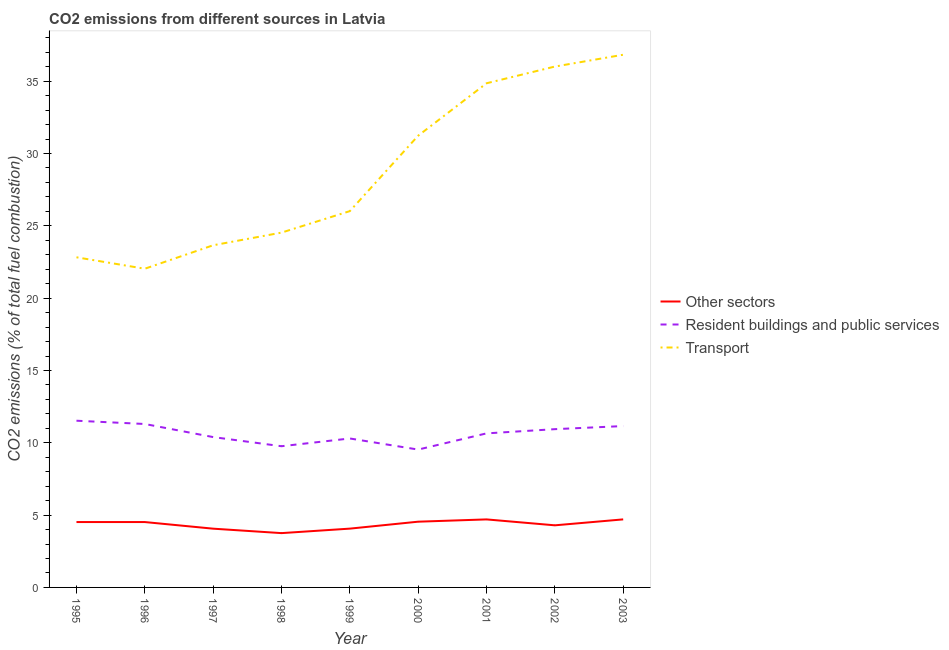Does the line corresponding to percentage of co2 emissions from transport intersect with the line corresponding to percentage of co2 emissions from other sectors?
Your answer should be compact. No. What is the percentage of co2 emissions from transport in 2003?
Keep it short and to the point. 36.83. Across all years, what is the maximum percentage of co2 emissions from other sectors?
Provide a short and direct response. 4.7. Across all years, what is the minimum percentage of co2 emissions from resident buildings and public services?
Offer a very short reply. 9.53. What is the total percentage of co2 emissions from resident buildings and public services in the graph?
Provide a short and direct response. 95.56. What is the difference between the percentage of co2 emissions from other sectors in 1999 and that in 2001?
Your answer should be very brief. -0.64. What is the difference between the percentage of co2 emissions from transport in 1999 and the percentage of co2 emissions from resident buildings and public services in 1998?
Keep it short and to the point. 16.25. What is the average percentage of co2 emissions from resident buildings and public services per year?
Offer a very short reply. 10.62. In the year 1997, what is the difference between the percentage of co2 emissions from transport and percentage of co2 emissions from other sectors?
Provide a short and direct response. 19.59. What is the ratio of the percentage of co2 emissions from transport in 1996 to that in 2001?
Offer a very short reply. 0.63. Is the percentage of co2 emissions from resident buildings and public services in 1997 less than that in 2001?
Keep it short and to the point. Yes. Is the difference between the percentage of co2 emissions from other sectors in 1997 and 1998 greater than the difference between the percentage of co2 emissions from resident buildings and public services in 1997 and 1998?
Your answer should be very brief. No. What is the difference between the highest and the second highest percentage of co2 emissions from other sectors?
Provide a short and direct response. 0. What is the difference between the highest and the lowest percentage of co2 emissions from transport?
Offer a very short reply. 14.79. Is the sum of the percentage of co2 emissions from other sectors in 1996 and 2000 greater than the maximum percentage of co2 emissions from transport across all years?
Offer a terse response. No. Is it the case that in every year, the sum of the percentage of co2 emissions from other sectors and percentage of co2 emissions from resident buildings and public services is greater than the percentage of co2 emissions from transport?
Provide a succinct answer. No. How many lines are there?
Keep it short and to the point. 3. What is the difference between two consecutive major ticks on the Y-axis?
Ensure brevity in your answer.  5. Are the values on the major ticks of Y-axis written in scientific E-notation?
Keep it short and to the point. No. How are the legend labels stacked?
Provide a short and direct response. Vertical. What is the title of the graph?
Your answer should be very brief. CO2 emissions from different sources in Latvia. Does "Unpaid family workers" appear as one of the legend labels in the graph?
Offer a very short reply. No. What is the label or title of the X-axis?
Your answer should be very brief. Year. What is the label or title of the Y-axis?
Keep it short and to the point. CO2 emissions (% of total fuel combustion). What is the CO2 emissions (% of total fuel combustion) of Other sectors in 1995?
Provide a short and direct response. 4.52. What is the CO2 emissions (% of total fuel combustion) of Resident buildings and public services in 1995?
Provide a short and direct response. 11.53. What is the CO2 emissions (% of total fuel combustion) of Transport in 1995?
Make the answer very short. 22.82. What is the CO2 emissions (% of total fuel combustion) in Other sectors in 1996?
Give a very brief answer. 4.52. What is the CO2 emissions (% of total fuel combustion) in Resident buildings and public services in 1996?
Your answer should be very brief. 11.3. What is the CO2 emissions (% of total fuel combustion) of Transport in 1996?
Offer a very short reply. 22.03. What is the CO2 emissions (% of total fuel combustion) of Other sectors in 1997?
Keep it short and to the point. 4.06. What is the CO2 emissions (% of total fuel combustion) in Resident buildings and public services in 1997?
Your answer should be very brief. 10.39. What is the CO2 emissions (% of total fuel combustion) in Transport in 1997?
Ensure brevity in your answer.  23.66. What is the CO2 emissions (% of total fuel combustion) in Other sectors in 1998?
Make the answer very short. 3.75. What is the CO2 emissions (% of total fuel combustion) of Resident buildings and public services in 1998?
Offer a terse response. 9.76. What is the CO2 emissions (% of total fuel combustion) of Transport in 1998?
Your response must be concise. 24.53. What is the CO2 emissions (% of total fuel combustion) of Other sectors in 1999?
Your answer should be very brief. 4.07. What is the CO2 emissions (% of total fuel combustion) in Resident buildings and public services in 1999?
Give a very brief answer. 10.3. What is the CO2 emissions (% of total fuel combustion) of Transport in 1999?
Make the answer very short. 26.02. What is the CO2 emissions (% of total fuel combustion) in Other sectors in 2000?
Offer a terse response. 4.55. What is the CO2 emissions (% of total fuel combustion) in Resident buildings and public services in 2000?
Provide a short and direct response. 9.53. What is the CO2 emissions (% of total fuel combustion) of Transport in 2000?
Provide a succinct answer. 31.23. What is the CO2 emissions (% of total fuel combustion) in Other sectors in 2001?
Your answer should be very brief. 4.7. What is the CO2 emissions (% of total fuel combustion) of Resident buildings and public services in 2001?
Provide a short and direct response. 10.65. What is the CO2 emissions (% of total fuel combustion) in Transport in 2001?
Your answer should be very brief. 34.85. What is the CO2 emissions (% of total fuel combustion) in Other sectors in 2002?
Offer a very short reply. 4.29. What is the CO2 emissions (% of total fuel combustion) in Resident buildings and public services in 2002?
Keep it short and to the point. 10.94. What is the CO2 emissions (% of total fuel combustion) of Transport in 2002?
Give a very brief answer. 36.01. What is the CO2 emissions (% of total fuel combustion) of Other sectors in 2003?
Keep it short and to the point. 4.7. What is the CO2 emissions (% of total fuel combustion) of Resident buildings and public services in 2003?
Offer a very short reply. 11.16. What is the CO2 emissions (% of total fuel combustion) of Transport in 2003?
Provide a short and direct response. 36.83. Across all years, what is the maximum CO2 emissions (% of total fuel combustion) of Other sectors?
Your response must be concise. 4.7. Across all years, what is the maximum CO2 emissions (% of total fuel combustion) of Resident buildings and public services?
Give a very brief answer. 11.53. Across all years, what is the maximum CO2 emissions (% of total fuel combustion) of Transport?
Provide a short and direct response. 36.83. Across all years, what is the minimum CO2 emissions (% of total fuel combustion) of Other sectors?
Give a very brief answer. 3.75. Across all years, what is the minimum CO2 emissions (% of total fuel combustion) of Resident buildings and public services?
Give a very brief answer. 9.53. Across all years, what is the minimum CO2 emissions (% of total fuel combustion) of Transport?
Offer a terse response. 22.03. What is the total CO2 emissions (% of total fuel combustion) of Other sectors in the graph?
Offer a very short reply. 39.17. What is the total CO2 emissions (% of total fuel combustion) in Resident buildings and public services in the graph?
Keep it short and to the point. 95.56. What is the total CO2 emissions (% of total fuel combustion) in Transport in the graph?
Provide a succinct answer. 257.99. What is the difference between the CO2 emissions (% of total fuel combustion) of Resident buildings and public services in 1995 and that in 1996?
Your response must be concise. 0.23. What is the difference between the CO2 emissions (% of total fuel combustion) in Transport in 1995 and that in 1996?
Your answer should be compact. 0.79. What is the difference between the CO2 emissions (% of total fuel combustion) in Other sectors in 1995 and that in 1997?
Your response must be concise. 0.46. What is the difference between the CO2 emissions (% of total fuel combustion) of Resident buildings and public services in 1995 and that in 1997?
Give a very brief answer. 1.13. What is the difference between the CO2 emissions (% of total fuel combustion) of Transport in 1995 and that in 1997?
Make the answer very short. -0.83. What is the difference between the CO2 emissions (% of total fuel combustion) of Other sectors in 1995 and that in 1998?
Your answer should be very brief. 0.77. What is the difference between the CO2 emissions (% of total fuel combustion) in Resident buildings and public services in 1995 and that in 1998?
Your answer should be very brief. 1.76. What is the difference between the CO2 emissions (% of total fuel combustion) of Transport in 1995 and that in 1998?
Give a very brief answer. -1.71. What is the difference between the CO2 emissions (% of total fuel combustion) of Other sectors in 1995 and that in 1999?
Give a very brief answer. 0.45. What is the difference between the CO2 emissions (% of total fuel combustion) in Resident buildings and public services in 1995 and that in 1999?
Your response must be concise. 1.23. What is the difference between the CO2 emissions (% of total fuel combustion) of Transport in 1995 and that in 1999?
Your response must be concise. -3.19. What is the difference between the CO2 emissions (% of total fuel combustion) in Other sectors in 1995 and that in 2000?
Your response must be concise. -0.03. What is the difference between the CO2 emissions (% of total fuel combustion) of Resident buildings and public services in 1995 and that in 2000?
Give a very brief answer. 1.99. What is the difference between the CO2 emissions (% of total fuel combustion) in Transport in 1995 and that in 2000?
Give a very brief answer. -8.41. What is the difference between the CO2 emissions (% of total fuel combustion) in Other sectors in 1995 and that in 2001?
Offer a very short reply. -0.18. What is the difference between the CO2 emissions (% of total fuel combustion) in Resident buildings and public services in 1995 and that in 2001?
Your answer should be very brief. 0.88. What is the difference between the CO2 emissions (% of total fuel combustion) in Transport in 1995 and that in 2001?
Keep it short and to the point. -12.03. What is the difference between the CO2 emissions (% of total fuel combustion) in Other sectors in 1995 and that in 2002?
Your answer should be compact. 0.23. What is the difference between the CO2 emissions (% of total fuel combustion) in Resident buildings and public services in 1995 and that in 2002?
Give a very brief answer. 0.58. What is the difference between the CO2 emissions (% of total fuel combustion) of Transport in 1995 and that in 2002?
Your answer should be very brief. -13.19. What is the difference between the CO2 emissions (% of total fuel combustion) in Other sectors in 1995 and that in 2003?
Give a very brief answer. -0.18. What is the difference between the CO2 emissions (% of total fuel combustion) of Resident buildings and public services in 1995 and that in 2003?
Your answer should be very brief. 0.37. What is the difference between the CO2 emissions (% of total fuel combustion) of Transport in 1995 and that in 2003?
Make the answer very short. -14. What is the difference between the CO2 emissions (% of total fuel combustion) in Other sectors in 1996 and that in 1997?
Offer a very short reply. 0.46. What is the difference between the CO2 emissions (% of total fuel combustion) in Resident buildings and public services in 1996 and that in 1997?
Make the answer very short. 0.91. What is the difference between the CO2 emissions (% of total fuel combustion) of Transport in 1996 and that in 1997?
Ensure brevity in your answer.  -1.62. What is the difference between the CO2 emissions (% of total fuel combustion) in Other sectors in 1996 and that in 1998?
Provide a succinct answer. 0.77. What is the difference between the CO2 emissions (% of total fuel combustion) of Resident buildings and public services in 1996 and that in 1998?
Offer a very short reply. 1.54. What is the difference between the CO2 emissions (% of total fuel combustion) of Transport in 1996 and that in 1998?
Give a very brief answer. -2.5. What is the difference between the CO2 emissions (% of total fuel combustion) in Other sectors in 1996 and that in 1999?
Your answer should be very brief. 0.45. What is the difference between the CO2 emissions (% of total fuel combustion) of Transport in 1996 and that in 1999?
Provide a short and direct response. -3.98. What is the difference between the CO2 emissions (% of total fuel combustion) of Other sectors in 1996 and that in 2000?
Your response must be concise. -0.03. What is the difference between the CO2 emissions (% of total fuel combustion) of Resident buildings and public services in 1996 and that in 2000?
Your answer should be compact. 1.77. What is the difference between the CO2 emissions (% of total fuel combustion) in Transport in 1996 and that in 2000?
Your answer should be very brief. -9.2. What is the difference between the CO2 emissions (% of total fuel combustion) in Other sectors in 1996 and that in 2001?
Your answer should be very brief. -0.18. What is the difference between the CO2 emissions (% of total fuel combustion) in Resident buildings and public services in 1996 and that in 2001?
Your answer should be compact. 0.65. What is the difference between the CO2 emissions (% of total fuel combustion) in Transport in 1996 and that in 2001?
Keep it short and to the point. -12.82. What is the difference between the CO2 emissions (% of total fuel combustion) in Other sectors in 1996 and that in 2002?
Provide a short and direct response. 0.23. What is the difference between the CO2 emissions (% of total fuel combustion) of Resident buildings and public services in 1996 and that in 2002?
Ensure brevity in your answer.  0.36. What is the difference between the CO2 emissions (% of total fuel combustion) in Transport in 1996 and that in 2002?
Offer a very short reply. -13.98. What is the difference between the CO2 emissions (% of total fuel combustion) in Other sectors in 1996 and that in 2003?
Make the answer very short. -0.18. What is the difference between the CO2 emissions (% of total fuel combustion) of Resident buildings and public services in 1996 and that in 2003?
Your answer should be very brief. 0.14. What is the difference between the CO2 emissions (% of total fuel combustion) of Transport in 1996 and that in 2003?
Make the answer very short. -14.79. What is the difference between the CO2 emissions (% of total fuel combustion) of Other sectors in 1997 and that in 1998?
Keep it short and to the point. 0.31. What is the difference between the CO2 emissions (% of total fuel combustion) in Resident buildings and public services in 1997 and that in 1998?
Ensure brevity in your answer.  0.63. What is the difference between the CO2 emissions (% of total fuel combustion) of Transport in 1997 and that in 1998?
Give a very brief answer. -0.87. What is the difference between the CO2 emissions (% of total fuel combustion) in Other sectors in 1997 and that in 1999?
Your response must be concise. -0. What is the difference between the CO2 emissions (% of total fuel combustion) of Resident buildings and public services in 1997 and that in 1999?
Provide a succinct answer. 0.1. What is the difference between the CO2 emissions (% of total fuel combustion) of Transport in 1997 and that in 1999?
Keep it short and to the point. -2.36. What is the difference between the CO2 emissions (% of total fuel combustion) in Other sectors in 1997 and that in 2000?
Your response must be concise. -0.48. What is the difference between the CO2 emissions (% of total fuel combustion) of Resident buildings and public services in 1997 and that in 2000?
Ensure brevity in your answer.  0.86. What is the difference between the CO2 emissions (% of total fuel combustion) in Transport in 1997 and that in 2000?
Provide a succinct answer. -7.58. What is the difference between the CO2 emissions (% of total fuel combustion) in Other sectors in 1997 and that in 2001?
Your answer should be very brief. -0.64. What is the difference between the CO2 emissions (% of total fuel combustion) in Resident buildings and public services in 1997 and that in 2001?
Ensure brevity in your answer.  -0.26. What is the difference between the CO2 emissions (% of total fuel combustion) of Transport in 1997 and that in 2001?
Keep it short and to the point. -11.2. What is the difference between the CO2 emissions (% of total fuel combustion) of Other sectors in 1997 and that in 2002?
Give a very brief answer. -0.23. What is the difference between the CO2 emissions (% of total fuel combustion) of Resident buildings and public services in 1997 and that in 2002?
Offer a very short reply. -0.55. What is the difference between the CO2 emissions (% of total fuel combustion) in Transport in 1997 and that in 2002?
Make the answer very short. -12.36. What is the difference between the CO2 emissions (% of total fuel combustion) in Other sectors in 1997 and that in 2003?
Your response must be concise. -0.64. What is the difference between the CO2 emissions (% of total fuel combustion) of Resident buildings and public services in 1997 and that in 2003?
Your answer should be compact. -0.76. What is the difference between the CO2 emissions (% of total fuel combustion) in Transport in 1997 and that in 2003?
Keep it short and to the point. -13.17. What is the difference between the CO2 emissions (% of total fuel combustion) in Other sectors in 1998 and that in 1999?
Provide a short and direct response. -0.31. What is the difference between the CO2 emissions (% of total fuel combustion) in Resident buildings and public services in 1998 and that in 1999?
Give a very brief answer. -0.54. What is the difference between the CO2 emissions (% of total fuel combustion) of Transport in 1998 and that in 1999?
Your response must be concise. -1.49. What is the difference between the CO2 emissions (% of total fuel combustion) in Other sectors in 1998 and that in 2000?
Provide a succinct answer. -0.79. What is the difference between the CO2 emissions (% of total fuel combustion) of Resident buildings and public services in 1998 and that in 2000?
Offer a terse response. 0.23. What is the difference between the CO2 emissions (% of total fuel combustion) of Transport in 1998 and that in 2000?
Give a very brief answer. -6.7. What is the difference between the CO2 emissions (% of total fuel combustion) of Other sectors in 1998 and that in 2001?
Ensure brevity in your answer.  -0.95. What is the difference between the CO2 emissions (% of total fuel combustion) in Resident buildings and public services in 1998 and that in 2001?
Provide a succinct answer. -0.89. What is the difference between the CO2 emissions (% of total fuel combustion) of Transport in 1998 and that in 2001?
Provide a short and direct response. -10.32. What is the difference between the CO2 emissions (% of total fuel combustion) of Other sectors in 1998 and that in 2002?
Make the answer very short. -0.54. What is the difference between the CO2 emissions (% of total fuel combustion) in Resident buildings and public services in 1998 and that in 2002?
Offer a terse response. -1.18. What is the difference between the CO2 emissions (% of total fuel combustion) in Transport in 1998 and that in 2002?
Ensure brevity in your answer.  -11.48. What is the difference between the CO2 emissions (% of total fuel combustion) of Other sectors in 1998 and that in 2003?
Make the answer very short. -0.95. What is the difference between the CO2 emissions (% of total fuel combustion) in Resident buildings and public services in 1998 and that in 2003?
Keep it short and to the point. -1.39. What is the difference between the CO2 emissions (% of total fuel combustion) in Transport in 1998 and that in 2003?
Your response must be concise. -12.3. What is the difference between the CO2 emissions (% of total fuel combustion) in Other sectors in 1999 and that in 2000?
Give a very brief answer. -0.48. What is the difference between the CO2 emissions (% of total fuel combustion) of Resident buildings and public services in 1999 and that in 2000?
Make the answer very short. 0.77. What is the difference between the CO2 emissions (% of total fuel combustion) in Transport in 1999 and that in 2000?
Ensure brevity in your answer.  -5.22. What is the difference between the CO2 emissions (% of total fuel combustion) of Other sectors in 1999 and that in 2001?
Offer a very short reply. -0.64. What is the difference between the CO2 emissions (% of total fuel combustion) in Resident buildings and public services in 1999 and that in 2001?
Your answer should be very brief. -0.35. What is the difference between the CO2 emissions (% of total fuel combustion) in Transport in 1999 and that in 2001?
Provide a succinct answer. -8.84. What is the difference between the CO2 emissions (% of total fuel combustion) in Other sectors in 1999 and that in 2002?
Offer a very short reply. -0.23. What is the difference between the CO2 emissions (% of total fuel combustion) of Resident buildings and public services in 1999 and that in 2002?
Provide a succinct answer. -0.64. What is the difference between the CO2 emissions (% of total fuel combustion) of Transport in 1999 and that in 2002?
Provide a short and direct response. -9.99. What is the difference between the CO2 emissions (% of total fuel combustion) in Other sectors in 1999 and that in 2003?
Provide a succinct answer. -0.64. What is the difference between the CO2 emissions (% of total fuel combustion) in Resident buildings and public services in 1999 and that in 2003?
Provide a succinct answer. -0.86. What is the difference between the CO2 emissions (% of total fuel combustion) in Transport in 1999 and that in 2003?
Offer a terse response. -10.81. What is the difference between the CO2 emissions (% of total fuel combustion) in Other sectors in 2000 and that in 2001?
Offer a terse response. -0.16. What is the difference between the CO2 emissions (% of total fuel combustion) in Resident buildings and public services in 2000 and that in 2001?
Your response must be concise. -1.12. What is the difference between the CO2 emissions (% of total fuel combustion) in Transport in 2000 and that in 2001?
Provide a succinct answer. -3.62. What is the difference between the CO2 emissions (% of total fuel combustion) of Other sectors in 2000 and that in 2002?
Make the answer very short. 0.25. What is the difference between the CO2 emissions (% of total fuel combustion) in Resident buildings and public services in 2000 and that in 2002?
Ensure brevity in your answer.  -1.41. What is the difference between the CO2 emissions (% of total fuel combustion) in Transport in 2000 and that in 2002?
Keep it short and to the point. -4.78. What is the difference between the CO2 emissions (% of total fuel combustion) in Other sectors in 2000 and that in 2003?
Your answer should be compact. -0.16. What is the difference between the CO2 emissions (% of total fuel combustion) in Resident buildings and public services in 2000 and that in 2003?
Your answer should be compact. -1.63. What is the difference between the CO2 emissions (% of total fuel combustion) in Transport in 2000 and that in 2003?
Make the answer very short. -5.6. What is the difference between the CO2 emissions (% of total fuel combustion) of Other sectors in 2001 and that in 2002?
Offer a terse response. 0.41. What is the difference between the CO2 emissions (% of total fuel combustion) of Resident buildings and public services in 2001 and that in 2002?
Make the answer very short. -0.29. What is the difference between the CO2 emissions (% of total fuel combustion) in Transport in 2001 and that in 2002?
Keep it short and to the point. -1.16. What is the difference between the CO2 emissions (% of total fuel combustion) in Other sectors in 2001 and that in 2003?
Ensure brevity in your answer.  -0. What is the difference between the CO2 emissions (% of total fuel combustion) of Resident buildings and public services in 2001 and that in 2003?
Offer a terse response. -0.51. What is the difference between the CO2 emissions (% of total fuel combustion) in Transport in 2001 and that in 2003?
Keep it short and to the point. -1.97. What is the difference between the CO2 emissions (% of total fuel combustion) in Other sectors in 2002 and that in 2003?
Your answer should be very brief. -0.41. What is the difference between the CO2 emissions (% of total fuel combustion) of Resident buildings and public services in 2002 and that in 2003?
Your answer should be compact. -0.21. What is the difference between the CO2 emissions (% of total fuel combustion) of Transport in 2002 and that in 2003?
Make the answer very short. -0.82. What is the difference between the CO2 emissions (% of total fuel combustion) in Other sectors in 1995 and the CO2 emissions (% of total fuel combustion) in Resident buildings and public services in 1996?
Provide a succinct answer. -6.78. What is the difference between the CO2 emissions (% of total fuel combustion) of Other sectors in 1995 and the CO2 emissions (% of total fuel combustion) of Transport in 1996?
Your response must be concise. -17.51. What is the difference between the CO2 emissions (% of total fuel combustion) of Resident buildings and public services in 1995 and the CO2 emissions (% of total fuel combustion) of Transport in 1996?
Keep it short and to the point. -10.51. What is the difference between the CO2 emissions (% of total fuel combustion) of Other sectors in 1995 and the CO2 emissions (% of total fuel combustion) of Resident buildings and public services in 1997?
Offer a very short reply. -5.87. What is the difference between the CO2 emissions (% of total fuel combustion) in Other sectors in 1995 and the CO2 emissions (% of total fuel combustion) in Transport in 1997?
Provide a short and direct response. -19.14. What is the difference between the CO2 emissions (% of total fuel combustion) of Resident buildings and public services in 1995 and the CO2 emissions (% of total fuel combustion) of Transport in 1997?
Provide a succinct answer. -12.13. What is the difference between the CO2 emissions (% of total fuel combustion) of Other sectors in 1995 and the CO2 emissions (% of total fuel combustion) of Resident buildings and public services in 1998?
Keep it short and to the point. -5.24. What is the difference between the CO2 emissions (% of total fuel combustion) in Other sectors in 1995 and the CO2 emissions (% of total fuel combustion) in Transport in 1998?
Your answer should be compact. -20.01. What is the difference between the CO2 emissions (% of total fuel combustion) of Resident buildings and public services in 1995 and the CO2 emissions (% of total fuel combustion) of Transport in 1998?
Offer a terse response. -13.01. What is the difference between the CO2 emissions (% of total fuel combustion) in Other sectors in 1995 and the CO2 emissions (% of total fuel combustion) in Resident buildings and public services in 1999?
Make the answer very short. -5.78. What is the difference between the CO2 emissions (% of total fuel combustion) of Other sectors in 1995 and the CO2 emissions (% of total fuel combustion) of Transport in 1999?
Provide a succinct answer. -21.5. What is the difference between the CO2 emissions (% of total fuel combustion) in Resident buildings and public services in 1995 and the CO2 emissions (% of total fuel combustion) in Transport in 1999?
Make the answer very short. -14.49. What is the difference between the CO2 emissions (% of total fuel combustion) of Other sectors in 1995 and the CO2 emissions (% of total fuel combustion) of Resident buildings and public services in 2000?
Make the answer very short. -5.01. What is the difference between the CO2 emissions (% of total fuel combustion) of Other sectors in 1995 and the CO2 emissions (% of total fuel combustion) of Transport in 2000?
Provide a succinct answer. -26.71. What is the difference between the CO2 emissions (% of total fuel combustion) of Resident buildings and public services in 1995 and the CO2 emissions (% of total fuel combustion) of Transport in 2000?
Your answer should be very brief. -19.71. What is the difference between the CO2 emissions (% of total fuel combustion) in Other sectors in 1995 and the CO2 emissions (% of total fuel combustion) in Resident buildings and public services in 2001?
Offer a terse response. -6.13. What is the difference between the CO2 emissions (% of total fuel combustion) in Other sectors in 1995 and the CO2 emissions (% of total fuel combustion) in Transport in 2001?
Give a very brief answer. -30.34. What is the difference between the CO2 emissions (% of total fuel combustion) of Resident buildings and public services in 1995 and the CO2 emissions (% of total fuel combustion) of Transport in 2001?
Offer a very short reply. -23.33. What is the difference between the CO2 emissions (% of total fuel combustion) in Other sectors in 1995 and the CO2 emissions (% of total fuel combustion) in Resident buildings and public services in 2002?
Make the answer very short. -6.42. What is the difference between the CO2 emissions (% of total fuel combustion) of Other sectors in 1995 and the CO2 emissions (% of total fuel combustion) of Transport in 2002?
Provide a succinct answer. -31.49. What is the difference between the CO2 emissions (% of total fuel combustion) in Resident buildings and public services in 1995 and the CO2 emissions (% of total fuel combustion) in Transport in 2002?
Provide a short and direct response. -24.49. What is the difference between the CO2 emissions (% of total fuel combustion) of Other sectors in 1995 and the CO2 emissions (% of total fuel combustion) of Resident buildings and public services in 2003?
Keep it short and to the point. -6.64. What is the difference between the CO2 emissions (% of total fuel combustion) in Other sectors in 1995 and the CO2 emissions (% of total fuel combustion) in Transport in 2003?
Provide a succinct answer. -32.31. What is the difference between the CO2 emissions (% of total fuel combustion) of Resident buildings and public services in 1995 and the CO2 emissions (% of total fuel combustion) of Transport in 2003?
Give a very brief answer. -25.3. What is the difference between the CO2 emissions (% of total fuel combustion) of Other sectors in 1996 and the CO2 emissions (% of total fuel combustion) of Resident buildings and public services in 1997?
Make the answer very short. -5.87. What is the difference between the CO2 emissions (% of total fuel combustion) of Other sectors in 1996 and the CO2 emissions (% of total fuel combustion) of Transport in 1997?
Offer a terse response. -19.14. What is the difference between the CO2 emissions (% of total fuel combustion) in Resident buildings and public services in 1996 and the CO2 emissions (% of total fuel combustion) in Transport in 1997?
Keep it short and to the point. -12.36. What is the difference between the CO2 emissions (% of total fuel combustion) of Other sectors in 1996 and the CO2 emissions (% of total fuel combustion) of Resident buildings and public services in 1998?
Provide a succinct answer. -5.24. What is the difference between the CO2 emissions (% of total fuel combustion) of Other sectors in 1996 and the CO2 emissions (% of total fuel combustion) of Transport in 1998?
Your response must be concise. -20.01. What is the difference between the CO2 emissions (% of total fuel combustion) of Resident buildings and public services in 1996 and the CO2 emissions (% of total fuel combustion) of Transport in 1998?
Provide a succinct answer. -13.23. What is the difference between the CO2 emissions (% of total fuel combustion) of Other sectors in 1996 and the CO2 emissions (% of total fuel combustion) of Resident buildings and public services in 1999?
Give a very brief answer. -5.78. What is the difference between the CO2 emissions (% of total fuel combustion) in Other sectors in 1996 and the CO2 emissions (% of total fuel combustion) in Transport in 1999?
Make the answer very short. -21.5. What is the difference between the CO2 emissions (% of total fuel combustion) of Resident buildings and public services in 1996 and the CO2 emissions (% of total fuel combustion) of Transport in 1999?
Offer a very short reply. -14.72. What is the difference between the CO2 emissions (% of total fuel combustion) of Other sectors in 1996 and the CO2 emissions (% of total fuel combustion) of Resident buildings and public services in 2000?
Give a very brief answer. -5.01. What is the difference between the CO2 emissions (% of total fuel combustion) in Other sectors in 1996 and the CO2 emissions (% of total fuel combustion) in Transport in 2000?
Provide a succinct answer. -26.71. What is the difference between the CO2 emissions (% of total fuel combustion) of Resident buildings and public services in 1996 and the CO2 emissions (% of total fuel combustion) of Transport in 2000?
Offer a very short reply. -19.93. What is the difference between the CO2 emissions (% of total fuel combustion) of Other sectors in 1996 and the CO2 emissions (% of total fuel combustion) of Resident buildings and public services in 2001?
Ensure brevity in your answer.  -6.13. What is the difference between the CO2 emissions (% of total fuel combustion) in Other sectors in 1996 and the CO2 emissions (% of total fuel combustion) in Transport in 2001?
Offer a very short reply. -30.34. What is the difference between the CO2 emissions (% of total fuel combustion) of Resident buildings and public services in 1996 and the CO2 emissions (% of total fuel combustion) of Transport in 2001?
Your answer should be compact. -23.56. What is the difference between the CO2 emissions (% of total fuel combustion) of Other sectors in 1996 and the CO2 emissions (% of total fuel combustion) of Resident buildings and public services in 2002?
Your response must be concise. -6.42. What is the difference between the CO2 emissions (% of total fuel combustion) of Other sectors in 1996 and the CO2 emissions (% of total fuel combustion) of Transport in 2002?
Your answer should be very brief. -31.49. What is the difference between the CO2 emissions (% of total fuel combustion) of Resident buildings and public services in 1996 and the CO2 emissions (% of total fuel combustion) of Transport in 2002?
Offer a very short reply. -24.71. What is the difference between the CO2 emissions (% of total fuel combustion) of Other sectors in 1996 and the CO2 emissions (% of total fuel combustion) of Resident buildings and public services in 2003?
Give a very brief answer. -6.64. What is the difference between the CO2 emissions (% of total fuel combustion) of Other sectors in 1996 and the CO2 emissions (% of total fuel combustion) of Transport in 2003?
Your answer should be compact. -32.31. What is the difference between the CO2 emissions (% of total fuel combustion) of Resident buildings and public services in 1996 and the CO2 emissions (% of total fuel combustion) of Transport in 2003?
Provide a short and direct response. -25.53. What is the difference between the CO2 emissions (% of total fuel combustion) of Other sectors in 1997 and the CO2 emissions (% of total fuel combustion) of Resident buildings and public services in 1998?
Provide a succinct answer. -5.7. What is the difference between the CO2 emissions (% of total fuel combustion) of Other sectors in 1997 and the CO2 emissions (% of total fuel combustion) of Transport in 1998?
Make the answer very short. -20.47. What is the difference between the CO2 emissions (% of total fuel combustion) in Resident buildings and public services in 1997 and the CO2 emissions (% of total fuel combustion) in Transport in 1998?
Your answer should be very brief. -14.14. What is the difference between the CO2 emissions (% of total fuel combustion) of Other sectors in 1997 and the CO2 emissions (% of total fuel combustion) of Resident buildings and public services in 1999?
Offer a very short reply. -6.24. What is the difference between the CO2 emissions (% of total fuel combustion) of Other sectors in 1997 and the CO2 emissions (% of total fuel combustion) of Transport in 1999?
Your response must be concise. -21.95. What is the difference between the CO2 emissions (% of total fuel combustion) of Resident buildings and public services in 1997 and the CO2 emissions (% of total fuel combustion) of Transport in 1999?
Your answer should be compact. -15.62. What is the difference between the CO2 emissions (% of total fuel combustion) in Other sectors in 1997 and the CO2 emissions (% of total fuel combustion) in Resident buildings and public services in 2000?
Give a very brief answer. -5.47. What is the difference between the CO2 emissions (% of total fuel combustion) in Other sectors in 1997 and the CO2 emissions (% of total fuel combustion) in Transport in 2000?
Your answer should be very brief. -27.17. What is the difference between the CO2 emissions (% of total fuel combustion) of Resident buildings and public services in 1997 and the CO2 emissions (% of total fuel combustion) of Transport in 2000?
Your answer should be very brief. -20.84. What is the difference between the CO2 emissions (% of total fuel combustion) of Other sectors in 1997 and the CO2 emissions (% of total fuel combustion) of Resident buildings and public services in 2001?
Give a very brief answer. -6.59. What is the difference between the CO2 emissions (% of total fuel combustion) in Other sectors in 1997 and the CO2 emissions (% of total fuel combustion) in Transport in 2001?
Provide a succinct answer. -30.79. What is the difference between the CO2 emissions (% of total fuel combustion) of Resident buildings and public services in 1997 and the CO2 emissions (% of total fuel combustion) of Transport in 2001?
Provide a short and direct response. -24.46. What is the difference between the CO2 emissions (% of total fuel combustion) in Other sectors in 1997 and the CO2 emissions (% of total fuel combustion) in Resident buildings and public services in 2002?
Give a very brief answer. -6.88. What is the difference between the CO2 emissions (% of total fuel combustion) in Other sectors in 1997 and the CO2 emissions (% of total fuel combustion) in Transport in 2002?
Keep it short and to the point. -31.95. What is the difference between the CO2 emissions (% of total fuel combustion) of Resident buildings and public services in 1997 and the CO2 emissions (% of total fuel combustion) of Transport in 2002?
Offer a terse response. -25.62. What is the difference between the CO2 emissions (% of total fuel combustion) in Other sectors in 1997 and the CO2 emissions (% of total fuel combustion) in Resident buildings and public services in 2003?
Your response must be concise. -7.09. What is the difference between the CO2 emissions (% of total fuel combustion) in Other sectors in 1997 and the CO2 emissions (% of total fuel combustion) in Transport in 2003?
Make the answer very short. -32.77. What is the difference between the CO2 emissions (% of total fuel combustion) of Resident buildings and public services in 1997 and the CO2 emissions (% of total fuel combustion) of Transport in 2003?
Give a very brief answer. -26.43. What is the difference between the CO2 emissions (% of total fuel combustion) of Other sectors in 1998 and the CO2 emissions (% of total fuel combustion) of Resident buildings and public services in 1999?
Your answer should be compact. -6.54. What is the difference between the CO2 emissions (% of total fuel combustion) of Other sectors in 1998 and the CO2 emissions (% of total fuel combustion) of Transport in 1999?
Offer a very short reply. -22.26. What is the difference between the CO2 emissions (% of total fuel combustion) of Resident buildings and public services in 1998 and the CO2 emissions (% of total fuel combustion) of Transport in 1999?
Make the answer very short. -16.25. What is the difference between the CO2 emissions (% of total fuel combustion) in Other sectors in 1998 and the CO2 emissions (% of total fuel combustion) in Resident buildings and public services in 2000?
Provide a short and direct response. -5.78. What is the difference between the CO2 emissions (% of total fuel combustion) in Other sectors in 1998 and the CO2 emissions (% of total fuel combustion) in Transport in 2000?
Offer a terse response. -27.48. What is the difference between the CO2 emissions (% of total fuel combustion) in Resident buildings and public services in 1998 and the CO2 emissions (% of total fuel combustion) in Transport in 2000?
Your answer should be very brief. -21.47. What is the difference between the CO2 emissions (% of total fuel combustion) of Other sectors in 1998 and the CO2 emissions (% of total fuel combustion) of Resident buildings and public services in 2001?
Keep it short and to the point. -6.9. What is the difference between the CO2 emissions (% of total fuel combustion) of Other sectors in 1998 and the CO2 emissions (% of total fuel combustion) of Transport in 2001?
Offer a terse response. -31.1. What is the difference between the CO2 emissions (% of total fuel combustion) in Resident buildings and public services in 1998 and the CO2 emissions (% of total fuel combustion) in Transport in 2001?
Give a very brief answer. -25.09. What is the difference between the CO2 emissions (% of total fuel combustion) in Other sectors in 1998 and the CO2 emissions (% of total fuel combustion) in Resident buildings and public services in 2002?
Provide a short and direct response. -7.19. What is the difference between the CO2 emissions (% of total fuel combustion) of Other sectors in 1998 and the CO2 emissions (% of total fuel combustion) of Transport in 2002?
Offer a terse response. -32.26. What is the difference between the CO2 emissions (% of total fuel combustion) in Resident buildings and public services in 1998 and the CO2 emissions (% of total fuel combustion) in Transport in 2002?
Keep it short and to the point. -26.25. What is the difference between the CO2 emissions (% of total fuel combustion) of Other sectors in 1998 and the CO2 emissions (% of total fuel combustion) of Resident buildings and public services in 2003?
Give a very brief answer. -7.4. What is the difference between the CO2 emissions (% of total fuel combustion) of Other sectors in 1998 and the CO2 emissions (% of total fuel combustion) of Transport in 2003?
Provide a short and direct response. -33.07. What is the difference between the CO2 emissions (% of total fuel combustion) in Resident buildings and public services in 1998 and the CO2 emissions (% of total fuel combustion) in Transport in 2003?
Provide a short and direct response. -27.07. What is the difference between the CO2 emissions (% of total fuel combustion) in Other sectors in 1999 and the CO2 emissions (% of total fuel combustion) in Resident buildings and public services in 2000?
Your response must be concise. -5.47. What is the difference between the CO2 emissions (% of total fuel combustion) of Other sectors in 1999 and the CO2 emissions (% of total fuel combustion) of Transport in 2000?
Provide a succinct answer. -27.17. What is the difference between the CO2 emissions (% of total fuel combustion) of Resident buildings and public services in 1999 and the CO2 emissions (% of total fuel combustion) of Transport in 2000?
Ensure brevity in your answer.  -20.93. What is the difference between the CO2 emissions (% of total fuel combustion) of Other sectors in 1999 and the CO2 emissions (% of total fuel combustion) of Resident buildings and public services in 2001?
Give a very brief answer. -6.58. What is the difference between the CO2 emissions (% of total fuel combustion) of Other sectors in 1999 and the CO2 emissions (% of total fuel combustion) of Transport in 2001?
Your answer should be very brief. -30.79. What is the difference between the CO2 emissions (% of total fuel combustion) of Resident buildings and public services in 1999 and the CO2 emissions (% of total fuel combustion) of Transport in 2001?
Your response must be concise. -24.56. What is the difference between the CO2 emissions (% of total fuel combustion) of Other sectors in 1999 and the CO2 emissions (% of total fuel combustion) of Resident buildings and public services in 2002?
Offer a very short reply. -6.88. What is the difference between the CO2 emissions (% of total fuel combustion) of Other sectors in 1999 and the CO2 emissions (% of total fuel combustion) of Transport in 2002?
Give a very brief answer. -31.95. What is the difference between the CO2 emissions (% of total fuel combustion) in Resident buildings and public services in 1999 and the CO2 emissions (% of total fuel combustion) in Transport in 2002?
Offer a very short reply. -25.71. What is the difference between the CO2 emissions (% of total fuel combustion) in Other sectors in 1999 and the CO2 emissions (% of total fuel combustion) in Resident buildings and public services in 2003?
Offer a very short reply. -7.09. What is the difference between the CO2 emissions (% of total fuel combustion) of Other sectors in 1999 and the CO2 emissions (% of total fuel combustion) of Transport in 2003?
Your answer should be compact. -32.76. What is the difference between the CO2 emissions (% of total fuel combustion) of Resident buildings and public services in 1999 and the CO2 emissions (% of total fuel combustion) of Transport in 2003?
Keep it short and to the point. -26.53. What is the difference between the CO2 emissions (% of total fuel combustion) of Other sectors in 2000 and the CO2 emissions (% of total fuel combustion) of Resident buildings and public services in 2001?
Your response must be concise. -6.1. What is the difference between the CO2 emissions (% of total fuel combustion) of Other sectors in 2000 and the CO2 emissions (% of total fuel combustion) of Transport in 2001?
Your answer should be compact. -30.31. What is the difference between the CO2 emissions (% of total fuel combustion) in Resident buildings and public services in 2000 and the CO2 emissions (% of total fuel combustion) in Transport in 2001?
Your response must be concise. -25.32. What is the difference between the CO2 emissions (% of total fuel combustion) of Other sectors in 2000 and the CO2 emissions (% of total fuel combustion) of Resident buildings and public services in 2002?
Keep it short and to the point. -6.4. What is the difference between the CO2 emissions (% of total fuel combustion) in Other sectors in 2000 and the CO2 emissions (% of total fuel combustion) in Transport in 2002?
Your response must be concise. -31.47. What is the difference between the CO2 emissions (% of total fuel combustion) in Resident buildings and public services in 2000 and the CO2 emissions (% of total fuel combustion) in Transport in 2002?
Offer a terse response. -26.48. What is the difference between the CO2 emissions (% of total fuel combustion) of Other sectors in 2000 and the CO2 emissions (% of total fuel combustion) of Resident buildings and public services in 2003?
Ensure brevity in your answer.  -6.61. What is the difference between the CO2 emissions (% of total fuel combustion) in Other sectors in 2000 and the CO2 emissions (% of total fuel combustion) in Transport in 2003?
Make the answer very short. -32.28. What is the difference between the CO2 emissions (% of total fuel combustion) in Resident buildings and public services in 2000 and the CO2 emissions (% of total fuel combustion) in Transport in 2003?
Give a very brief answer. -27.3. What is the difference between the CO2 emissions (% of total fuel combustion) of Other sectors in 2001 and the CO2 emissions (% of total fuel combustion) of Resident buildings and public services in 2002?
Provide a short and direct response. -6.24. What is the difference between the CO2 emissions (% of total fuel combustion) of Other sectors in 2001 and the CO2 emissions (% of total fuel combustion) of Transport in 2002?
Make the answer very short. -31.31. What is the difference between the CO2 emissions (% of total fuel combustion) in Resident buildings and public services in 2001 and the CO2 emissions (% of total fuel combustion) in Transport in 2002?
Your answer should be compact. -25.36. What is the difference between the CO2 emissions (% of total fuel combustion) of Other sectors in 2001 and the CO2 emissions (% of total fuel combustion) of Resident buildings and public services in 2003?
Provide a succinct answer. -6.45. What is the difference between the CO2 emissions (% of total fuel combustion) of Other sectors in 2001 and the CO2 emissions (% of total fuel combustion) of Transport in 2003?
Your response must be concise. -32.13. What is the difference between the CO2 emissions (% of total fuel combustion) of Resident buildings and public services in 2001 and the CO2 emissions (% of total fuel combustion) of Transport in 2003?
Ensure brevity in your answer.  -26.18. What is the difference between the CO2 emissions (% of total fuel combustion) of Other sectors in 2002 and the CO2 emissions (% of total fuel combustion) of Resident buildings and public services in 2003?
Give a very brief answer. -6.86. What is the difference between the CO2 emissions (% of total fuel combustion) in Other sectors in 2002 and the CO2 emissions (% of total fuel combustion) in Transport in 2003?
Offer a very short reply. -32.53. What is the difference between the CO2 emissions (% of total fuel combustion) of Resident buildings and public services in 2002 and the CO2 emissions (% of total fuel combustion) of Transport in 2003?
Your response must be concise. -25.89. What is the average CO2 emissions (% of total fuel combustion) in Other sectors per year?
Ensure brevity in your answer.  4.35. What is the average CO2 emissions (% of total fuel combustion) in Resident buildings and public services per year?
Your response must be concise. 10.62. What is the average CO2 emissions (% of total fuel combustion) in Transport per year?
Your answer should be very brief. 28.67. In the year 1995, what is the difference between the CO2 emissions (% of total fuel combustion) in Other sectors and CO2 emissions (% of total fuel combustion) in Resident buildings and public services?
Your answer should be very brief. -7.01. In the year 1995, what is the difference between the CO2 emissions (% of total fuel combustion) in Other sectors and CO2 emissions (% of total fuel combustion) in Transport?
Your answer should be very brief. -18.31. In the year 1995, what is the difference between the CO2 emissions (% of total fuel combustion) of Resident buildings and public services and CO2 emissions (% of total fuel combustion) of Transport?
Your answer should be very brief. -11.3. In the year 1996, what is the difference between the CO2 emissions (% of total fuel combustion) of Other sectors and CO2 emissions (% of total fuel combustion) of Resident buildings and public services?
Your answer should be very brief. -6.78. In the year 1996, what is the difference between the CO2 emissions (% of total fuel combustion) of Other sectors and CO2 emissions (% of total fuel combustion) of Transport?
Offer a terse response. -17.51. In the year 1996, what is the difference between the CO2 emissions (% of total fuel combustion) in Resident buildings and public services and CO2 emissions (% of total fuel combustion) in Transport?
Offer a very short reply. -10.73. In the year 1997, what is the difference between the CO2 emissions (% of total fuel combustion) of Other sectors and CO2 emissions (% of total fuel combustion) of Resident buildings and public services?
Ensure brevity in your answer.  -6.33. In the year 1997, what is the difference between the CO2 emissions (% of total fuel combustion) in Other sectors and CO2 emissions (% of total fuel combustion) in Transport?
Provide a succinct answer. -19.59. In the year 1997, what is the difference between the CO2 emissions (% of total fuel combustion) of Resident buildings and public services and CO2 emissions (% of total fuel combustion) of Transport?
Make the answer very short. -13.26. In the year 1998, what is the difference between the CO2 emissions (% of total fuel combustion) in Other sectors and CO2 emissions (% of total fuel combustion) in Resident buildings and public services?
Give a very brief answer. -6.01. In the year 1998, what is the difference between the CO2 emissions (% of total fuel combustion) of Other sectors and CO2 emissions (% of total fuel combustion) of Transport?
Provide a succinct answer. -20.78. In the year 1998, what is the difference between the CO2 emissions (% of total fuel combustion) in Resident buildings and public services and CO2 emissions (% of total fuel combustion) in Transport?
Keep it short and to the point. -14.77. In the year 1999, what is the difference between the CO2 emissions (% of total fuel combustion) in Other sectors and CO2 emissions (% of total fuel combustion) in Resident buildings and public services?
Give a very brief answer. -6.23. In the year 1999, what is the difference between the CO2 emissions (% of total fuel combustion) of Other sectors and CO2 emissions (% of total fuel combustion) of Transport?
Provide a short and direct response. -21.95. In the year 1999, what is the difference between the CO2 emissions (% of total fuel combustion) in Resident buildings and public services and CO2 emissions (% of total fuel combustion) in Transport?
Give a very brief answer. -15.72. In the year 2000, what is the difference between the CO2 emissions (% of total fuel combustion) of Other sectors and CO2 emissions (% of total fuel combustion) of Resident buildings and public services?
Your answer should be very brief. -4.99. In the year 2000, what is the difference between the CO2 emissions (% of total fuel combustion) of Other sectors and CO2 emissions (% of total fuel combustion) of Transport?
Your answer should be compact. -26.69. In the year 2000, what is the difference between the CO2 emissions (% of total fuel combustion) in Resident buildings and public services and CO2 emissions (% of total fuel combustion) in Transport?
Your answer should be very brief. -21.7. In the year 2001, what is the difference between the CO2 emissions (% of total fuel combustion) of Other sectors and CO2 emissions (% of total fuel combustion) of Resident buildings and public services?
Provide a succinct answer. -5.95. In the year 2001, what is the difference between the CO2 emissions (% of total fuel combustion) of Other sectors and CO2 emissions (% of total fuel combustion) of Transport?
Your answer should be very brief. -30.15. In the year 2001, what is the difference between the CO2 emissions (% of total fuel combustion) of Resident buildings and public services and CO2 emissions (% of total fuel combustion) of Transport?
Your response must be concise. -24.2. In the year 2002, what is the difference between the CO2 emissions (% of total fuel combustion) in Other sectors and CO2 emissions (% of total fuel combustion) in Resident buildings and public services?
Offer a very short reply. -6.65. In the year 2002, what is the difference between the CO2 emissions (% of total fuel combustion) in Other sectors and CO2 emissions (% of total fuel combustion) in Transport?
Your answer should be compact. -31.72. In the year 2002, what is the difference between the CO2 emissions (% of total fuel combustion) of Resident buildings and public services and CO2 emissions (% of total fuel combustion) of Transport?
Your answer should be compact. -25.07. In the year 2003, what is the difference between the CO2 emissions (% of total fuel combustion) in Other sectors and CO2 emissions (% of total fuel combustion) in Resident buildings and public services?
Your answer should be very brief. -6.45. In the year 2003, what is the difference between the CO2 emissions (% of total fuel combustion) of Other sectors and CO2 emissions (% of total fuel combustion) of Transport?
Ensure brevity in your answer.  -32.12. In the year 2003, what is the difference between the CO2 emissions (% of total fuel combustion) in Resident buildings and public services and CO2 emissions (% of total fuel combustion) in Transport?
Offer a very short reply. -25.67. What is the ratio of the CO2 emissions (% of total fuel combustion) of Resident buildings and public services in 1995 to that in 1996?
Give a very brief answer. 1.02. What is the ratio of the CO2 emissions (% of total fuel combustion) in Transport in 1995 to that in 1996?
Your answer should be very brief. 1.04. What is the ratio of the CO2 emissions (% of total fuel combustion) in Other sectors in 1995 to that in 1997?
Your response must be concise. 1.11. What is the ratio of the CO2 emissions (% of total fuel combustion) in Resident buildings and public services in 1995 to that in 1997?
Offer a very short reply. 1.11. What is the ratio of the CO2 emissions (% of total fuel combustion) in Transport in 1995 to that in 1997?
Ensure brevity in your answer.  0.96. What is the ratio of the CO2 emissions (% of total fuel combustion) in Other sectors in 1995 to that in 1998?
Make the answer very short. 1.2. What is the ratio of the CO2 emissions (% of total fuel combustion) of Resident buildings and public services in 1995 to that in 1998?
Ensure brevity in your answer.  1.18. What is the ratio of the CO2 emissions (% of total fuel combustion) of Transport in 1995 to that in 1998?
Provide a succinct answer. 0.93. What is the ratio of the CO2 emissions (% of total fuel combustion) of Other sectors in 1995 to that in 1999?
Give a very brief answer. 1.11. What is the ratio of the CO2 emissions (% of total fuel combustion) in Resident buildings and public services in 1995 to that in 1999?
Your answer should be very brief. 1.12. What is the ratio of the CO2 emissions (% of total fuel combustion) of Transport in 1995 to that in 1999?
Give a very brief answer. 0.88. What is the ratio of the CO2 emissions (% of total fuel combustion) of Other sectors in 1995 to that in 2000?
Provide a succinct answer. 0.99. What is the ratio of the CO2 emissions (% of total fuel combustion) of Resident buildings and public services in 1995 to that in 2000?
Provide a short and direct response. 1.21. What is the ratio of the CO2 emissions (% of total fuel combustion) of Transport in 1995 to that in 2000?
Provide a succinct answer. 0.73. What is the ratio of the CO2 emissions (% of total fuel combustion) in Other sectors in 1995 to that in 2001?
Provide a short and direct response. 0.96. What is the ratio of the CO2 emissions (% of total fuel combustion) of Resident buildings and public services in 1995 to that in 2001?
Your response must be concise. 1.08. What is the ratio of the CO2 emissions (% of total fuel combustion) of Transport in 1995 to that in 2001?
Make the answer very short. 0.65. What is the ratio of the CO2 emissions (% of total fuel combustion) in Other sectors in 1995 to that in 2002?
Provide a succinct answer. 1.05. What is the ratio of the CO2 emissions (% of total fuel combustion) in Resident buildings and public services in 1995 to that in 2002?
Offer a very short reply. 1.05. What is the ratio of the CO2 emissions (% of total fuel combustion) in Transport in 1995 to that in 2002?
Give a very brief answer. 0.63. What is the ratio of the CO2 emissions (% of total fuel combustion) of Other sectors in 1995 to that in 2003?
Your response must be concise. 0.96. What is the ratio of the CO2 emissions (% of total fuel combustion) in Resident buildings and public services in 1995 to that in 2003?
Ensure brevity in your answer.  1.03. What is the ratio of the CO2 emissions (% of total fuel combustion) in Transport in 1995 to that in 2003?
Keep it short and to the point. 0.62. What is the ratio of the CO2 emissions (% of total fuel combustion) in Other sectors in 1996 to that in 1997?
Your answer should be compact. 1.11. What is the ratio of the CO2 emissions (% of total fuel combustion) of Resident buildings and public services in 1996 to that in 1997?
Your answer should be compact. 1.09. What is the ratio of the CO2 emissions (% of total fuel combustion) of Transport in 1996 to that in 1997?
Keep it short and to the point. 0.93. What is the ratio of the CO2 emissions (% of total fuel combustion) of Other sectors in 1996 to that in 1998?
Provide a succinct answer. 1.2. What is the ratio of the CO2 emissions (% of total fuel combustion) of Resident buildings and public services in 1996 to that in 1998?
Offer a terse response. 1.16. What is the ratio of the CO2 emissions (% of total fuel combustion) in Transport in 1996 to that in 1998?
Your response must be concise. 0.9. What is the ratio of the CO2 emissions (% of total fuel combustion) of Other sectors in 1996 to that in 1999?
Provide a succinct answer. 1.11. What is the ratio of the CO2 emissions (% of total fuel combustion) of Resident buildings and public services in 1996 to that in 1999?
Make the answer very short. 1.1. What is the ratio of the CO2 emissions (% of total fuel combustion) in Transport in 1996 to that in 1999?
Ensure brevity in your answer.  0.85. What is the ratio of the CO2 emissions (% of total fuel combustion) in Resident buildings and public services in 1996 to that in 2000?
Make the answer very short. 1.19. What is the ratio of the CO2 emissions (% of total fuel combustion) in Transport in 1996 to that in 2000?
Make the answer very short. 0.71. What is the ratio of the CO2 emissions (% of total fuel combustion) in Other sectors in 1996 to that in 2001?
Provide a succinct answer. 0.96. What is the ratio of the CO2 emissions (% of total fuel combustion) of Resident buildings and public services in 1996 to that in 2001?
Ensure brevity in your answer.  1.06. What is the ratio of the CO2 emissions (% of total fuel combustion) in Transport in 1996 to that in 2001?
Provide a succinct answer. 0.63. What is the ratio of the CO2 emissions (% of total fuel combustion) in Other sectors in 1996 to that in 2002?
Provide a short and direct response. 1.05. What is the ratio of the CO2 emissions (% of total fuel combustion) of Resident buildings and public services in 1996 to that in 2002?
Provide a succinct answer. 1.03. What is the ratio of the CO2 emissions (% of total fuel combustion) in Transport in 1996 to that in 2002?
Give a very brief answer. 0.61. What is the ratio of the CO2 emissions (% of total fuel combustion) in Other sectors in 1996 to that in 2003?
Offer a terse response. 0.96. What is the ratio of the CO2 emissions (% of total fuel combustion) of Resident buildings and public services in 1996 to that in 2003?
Offer a very short reply. 1.01. What is the ratio of the CO2 emissions (% of total fuel combustion) in Transport in 1996 to that in 2003?
Your response must be concise. 0.6. What is the ratio of the CO2 emissions (% of total fuel combustion) in Other sectors in 1997 to that in 1998?
Provide a short and direct response. 1.08. What is the ratio of the CO2 emissions (% of total fuel combustion) in Resident buildings and public services in 1997 to that in 1998?
Keep it short and to the point. 1.06. What is the ratio of the CO2 emissions (% of total fuel combustion) of Transport in 1997 to that in 1998?
Offer a very short reply. 0.96. What is the ratio of the CO2 emissions (% of total fuel combustion) in Other sectors in 1997 to that in 1999?
Offer a terse response. 1. What is the ratio of the CO2 emissions (% of total fuel combustion) in Resident buildings and public services in 1997 to that in 1999?
Offer a very short reply. 1.01. What is the ratio of the CO2 emissions (% of total fuel combustion) of Transport in 1997 to that in 1999?
Keep it short and to the point. 0.91. What is the ratio of the CO2 emissions (% of total fuel combustion) in Other sectors in 1997 to that in 2000?
Offer a terse response. 0.89. What is the ratio of the CO2 emissions (% of total fuel combustion) in Resident buildings and public services in 1997 to that in 2000?
Your answer should be very brief. 1.09. What is the ratio of the CO2 emissions (% of total fuel combustion) in Transport in 1997 to that in 2000?
Your answer should be very brief. 0.76. What is the ratio of the CO2 emissions (% of total fuel combustion) in Other sectors in 1997 to that in 2001?
Your answer should be very brief. 0.86. What is the ratio of the CO2 emissions (% of total fuel combustion) of Transport in 1997 to that in 2001?
Make the answer very short. 0.68. What is the ratio of the CO2 emissions (% of total fuel combustion) of Other sectors in 1997 to that in 2002?
Your answer should be compact. 0.95. What is the ratio of the CO2 emissions (% of total fuel combustion) in Resident buildings and public services in 1997 to that in 2002?
Keep it short and to the point. 0.95. What is the ratio of the CO2 emissions (% of total fuel combustion) in Transport in 1997 to that in 2002?
Offer a very short reply. 0.66. What is the ratio of the CO2 emissions (% of total fuel combustion) in Other sectors in 1997 to that in 2003?
Your answer should be compact. 0.86. What is the ratio of the CO2 emissions (% of total fuel combustion) in Resident buildings and public services in 1997 to that in 2003?
Ensure brevity in your answer.  0.93. What is the ratio of the CO2 emissions (% of total fuel combustion) of Transport in 1997 to that in 2003?
Provide a succinct answer. 0.64. What is the ratio of the CO2 emissions (% of total fuel combustion) of Other sectors in 1998 to that in 1999?
Provide a short and direct response. 0.92. What is the ratio of the CO2 emissions (% of total fuel combustion) of Resident buildings and public services in 1998 to that in 1999?
Your response must be concise. 0.95. What is the ratio of the CO2 emissions (% of total fuel combustion) in Transport in 1998 to that in 1999?
Give a very brief answer. 0.94. What is the ratio of the CO2 emissions (% of total fuel combustion) in Other sectors in 1998 to that in 2000?
Keep it short and to the point. 0.83. What is the ratio of the CO2 emissions (% of total fuel combustion) of Resident buildings and public services in 1998 to that in 2000?
Your answer should be compact. 1.02. What is the ratio of the CO2 emissions (% of total fuel combustion) in Transport in 1998 to that in 2000?
Ensure brevity in your answer.  0.79. What is the ratio of the CO2 emissions (% of total fuel combustion) of Other sectors in 1998 to that in 2001?
Make the answer very short. 0.8. What is the ratio of the CO2 emissions (% of total fuel combustion) of Resident buildings and public services in 1998 to that in 2001?
Give a very brief answer. 0.92. What is the ratio of the CO2 emissions (% of total fuel combustion) of Transport in 1998 to that in 2001?
Provide a succinct answer. 0.7. What is the ratio of the CO2 emissions (% of total fuel combustion) in Other sectors in 1998 to that in 2002?
Your response must be concise. 0.87. What is the ratio of the CO2 emissions (% of total fuel combustion) in Resident buildings and public services in 1998 to that in 2002?
Your answer should be very brief. 0.89. What is the ratio of the CO2 emissions (% of total fuel combustion) in Transport in 1998 to that in 2002?
Your answer should be very brief. 0.68. What is the ratio of the CO2 emissions (% of total fuel combustion) in Other sectors in 1998 to that in 2003?
Make the answer very short. 0.8. What is the ratio of the CO2 emissions (% of total fuel combustion) in Resident buildings and public services in 1998 to that in 2003?
Your answer should be very brief. 0.88. What is the ratio of the CO2 emissions (% of total fuel combustion) of Transport in 1998 to that in 2003?
Keep it short and to the point. 0.67. What is the ratio of the CO2 emissions (% of total fuel combustion) in Other sectors in 1999 to that in 2000?
Your answer should be very brief. 0.89. What is the ratio of the CO2 emissions (% of total fuel combustion) of Resident buildings and public services in 1999 to that in 2000?
Make the answer very short. 1.08. What is the ratio of the CO2 emissions (% of total fuel combustion) in Transport in 1999 to that in 2000?
Offer a terse response. 0.83. What is the ratio of the CO2 emissions (% of total fuel combustion) in Other sectors in 1999 to that in 2001?
Ensure brevity in your answer.  0.86. What is the ratio of the CO2 emissions (% of total fuel combustion) in Resident buildings and public services in 1999 to that in 2001?
Your response must be concise. 0.97. What is the ratio of the CO2 emissions (% of total fuel combustion) in Transport in 1999 to that in 2001?
Make the answer very short. 0.75. What is the ratio of the CO2 emissions (% of total fuel combustion) of Other sectors in 1999 to that in 2002?
Make the answer very short. 0.95. What is the ratio of the CO2 emissions (% of total fuel combustion) in Transport in 1999 to that in 2002?
Your answer should be very brief. 0.72. What is the ratio of the CO2 emissions (% of total fuel combustion) of Other sectors in 1999 to that in 2003?
Offer a very short reply. 0.86. What is the ratio of the CO2 emissions (% of total fuel combustion) in Transport in 1999 to that in 2003?
Provide a succinct answer. 0.71. What is the ratio of the CO2 emissions (% of total fuel combustion) in Other sectors in 2000 to that in 2001?
Offer a very short reply. 0.97. What is the ratio of the CO2 emissions (% of total fuel combustion) in Resident buildings and public services in 2000 to that in 2001?
Offer a very short reply. 0.89. What is the ratio of the CO2 emissions (% of total fuel combustion) in Transport in 2000 to that in 2001?
Offer a very short reply. 0.9. What is the ratio of the CO2 emissions (% of total fuel combustion) in Other sectors in 2000 to that in 2002?
Give a very brief answer. 1.06. What is the ratio of the CO2 emissions (% of total fuel combustion) in Resident buildings and public services in 2000 to that in 2002?
Your answer should be very brief. 0.87. What is the ratio of the CO2 emissions (% of total fuel combustion) of Transport in 2000 to that in 2002?
Make the answer very short. 0.87. What is the ratio of the CO2 emissions (% of total fuel combustion) of Other sectors in 2000 to that in 2003?
Offer a very short reply. 0.97. What is the ratio of the CO2 emissions (% of total fuel combustion) of Resident buildings and public services in 2000 to that in 2003?
Offer a very short reply. 0.85. What is the ratio of the CO2 emissions (% of total fuel combustion) of Transport in 2000 to that in 2003?
Offer a terse response. 0.85. What is the ratio of the CO2 emissions (% of total fuel combustion) of Other sectors in 2001 to that in 2002?
Make the answer very short. 1.1. What is the ratio of the CO2 emissions (% of total fuel combustion) in Resident buildings and public services in 2001 to that in 2002?
Ensure brevity in your answer.  0.97. What is the ratio of the CO2 emissions (% of total fuel combustion) of Transport in 2001 to that in 2002?
Offer a very short reply. 0.97. What is the ratio of the CO2 emissions (% of total fuel combustion) in Other sectors in 2001 to that in 2003?
Your answer should be very brief. 1. What is the ratio of the CO2 emissions (% of total fuel combustion) in Resident buildings and public services in 2001 to that in 2003?
Your answer should be very brief. 0.95. What is the ratio of the CO2 emissions (% of total fuel combustion) in Transport in 2001 to that in 2003?
Provide a short and direct response. 0.95. What is the ratio of the CO2 emissions (% of total fuel combustion) of Other sectors in 2002 to that in 2003?
Keep it short and to the point. 0.91. What is the ratio of the CO2 emissions (% of total fuel combustion) of Resident buildings and public services in 2002 to that in 2003?
Your response must be concise. 0.98. What is the ratio of the CO2 emissions (% of total fuel combustion) in Transport in 2002 to that in 2003?
Your answer should be compact. 0.98. What is the difference between the highest and the second highest CO2 emissions (% of total fuel combustion) in Other sectors?
Offer a terse response. 0. What is the difference between the highest and the second highest CO2 emissions (% of total fuel combustion) in Resident buildings and public services?
Offer a terse response. 0.23. What is the difference between the highest and the second highest CO2 emissions (% of total fuel combustion) of Transport?
Offer a terse response. 0.82. What is the difference between the highest and the lowest CO2 emissions (% of total fuel combustion) in Other sectors?
Provide a short and direct response. 0.95. What is the difference between the highest and the lowest CO2 emissions (% of total fuel combustion) of Resident buildings and public services?
Your answer should be compact. 1.99. What is the difference between the highest and the lowest CO2 emissions (% of total fuel combustion) of Transport?
Your response must be concise. 14.79. 